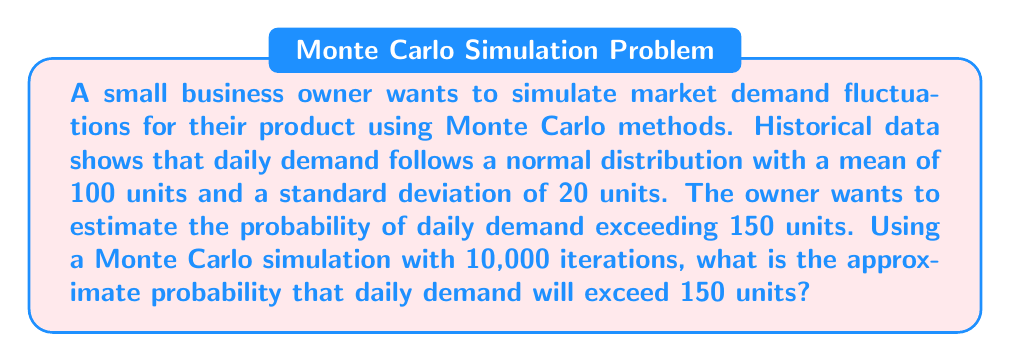Give your solution to this math problem. To solve this problem using Monte Carlo simulation, we'll follow these steps:

1. Set up the simulation parameters:
   - Number of iterations: 10,000
   - Mean daily demand: $\mu = 100$ units
   - Standard deviation of daily demand: $\sigma = 20$ units
   - Threshold: 150 units

2. Generate random samples:
   For each iteration, generate a random number from the normal distribution $N(\mu, \sigma)$ using the formula:
   $$X = \mu + \sigma \cdot Z$$
   where $Z$ is a standard normal random variable.

3. Count the number of times the generated demand exceeds 150 units.

4. Calculate the probability:
   $$P(\text{Demand} > 150) = \frac{\text{Number of times demand exceeded 150}}{\text{Total number of iterations}}$$

5. Implement the simulation (pseudo-code):
   ```
   count = 0
   for i = 1 to 10000:
       demand = 100 + 20 * random_standard_normal()
       if demand > 150:
           count = count + 1
   probability = count / 10000
   ```

6. Run the simulation multiple times to get an average result.

The theoretical probability can be calculated using the z-score:
$$z = \frac{150 - 100}{20} = 2.5$$
Using a standard normal table or calculator, we find:
$$P(Z > 2.5) \approx 0.0062$$

The Monte Carlo simulation should yield a result close to this theoretical probability.
Answer: Approximately 0.0062 or 0.62% 